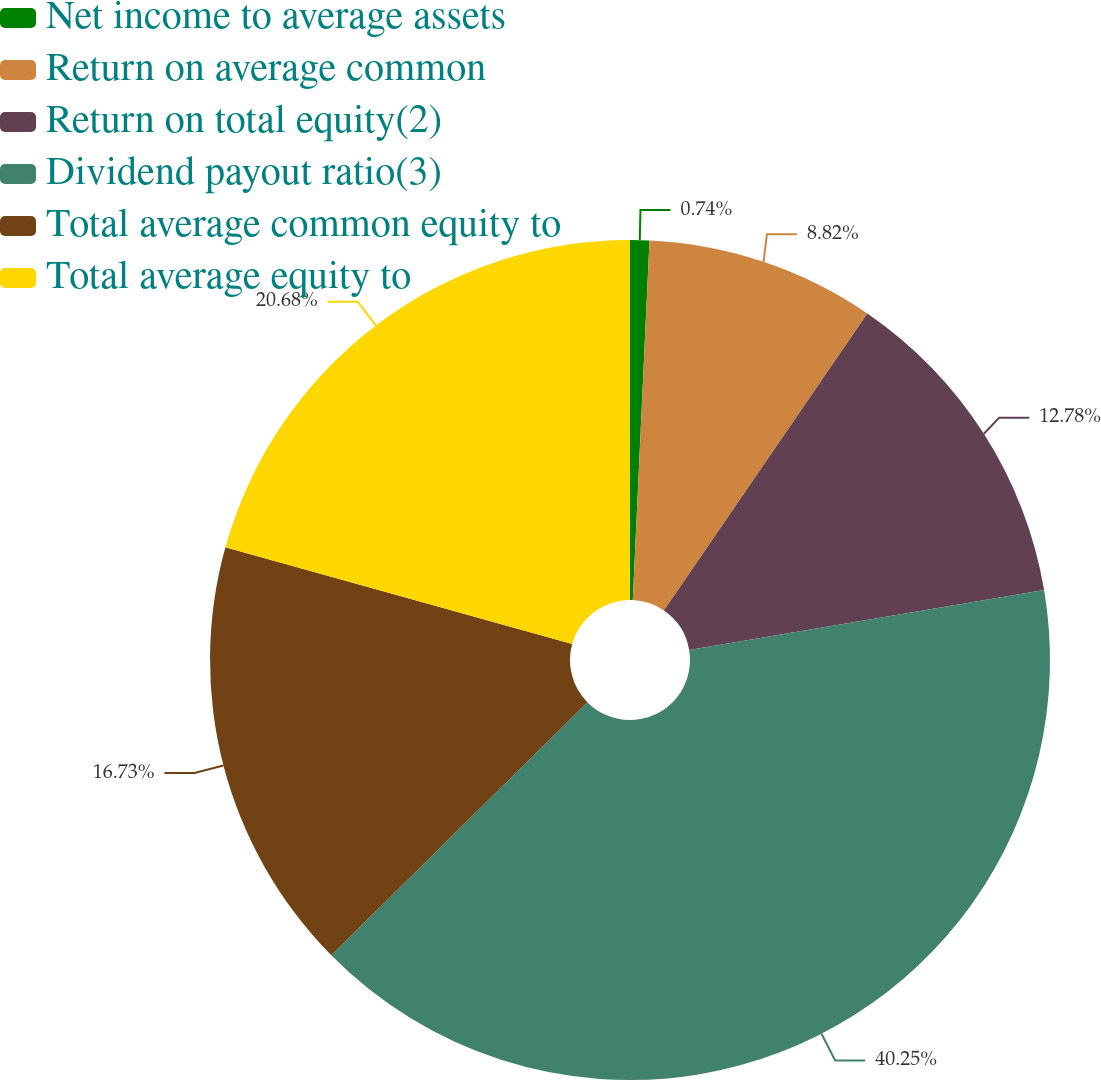Convert chart to OTSL. <chart><loc_0><loc_0><loc_500><loc_500><pie_chart><fcel>Net income to average assets<fcel>Return on average common<fcel>Return on total equity(2)<fcel>Dividend payout ratio(3)<fcel>Total average common equity to<fcel>Total average equity to<nl><fcel>0.74%<fcel>8.82%<fcel>12.78%<fcel>40.26%<fcel>16.73%<fcel>20.68%<nl></chart> 